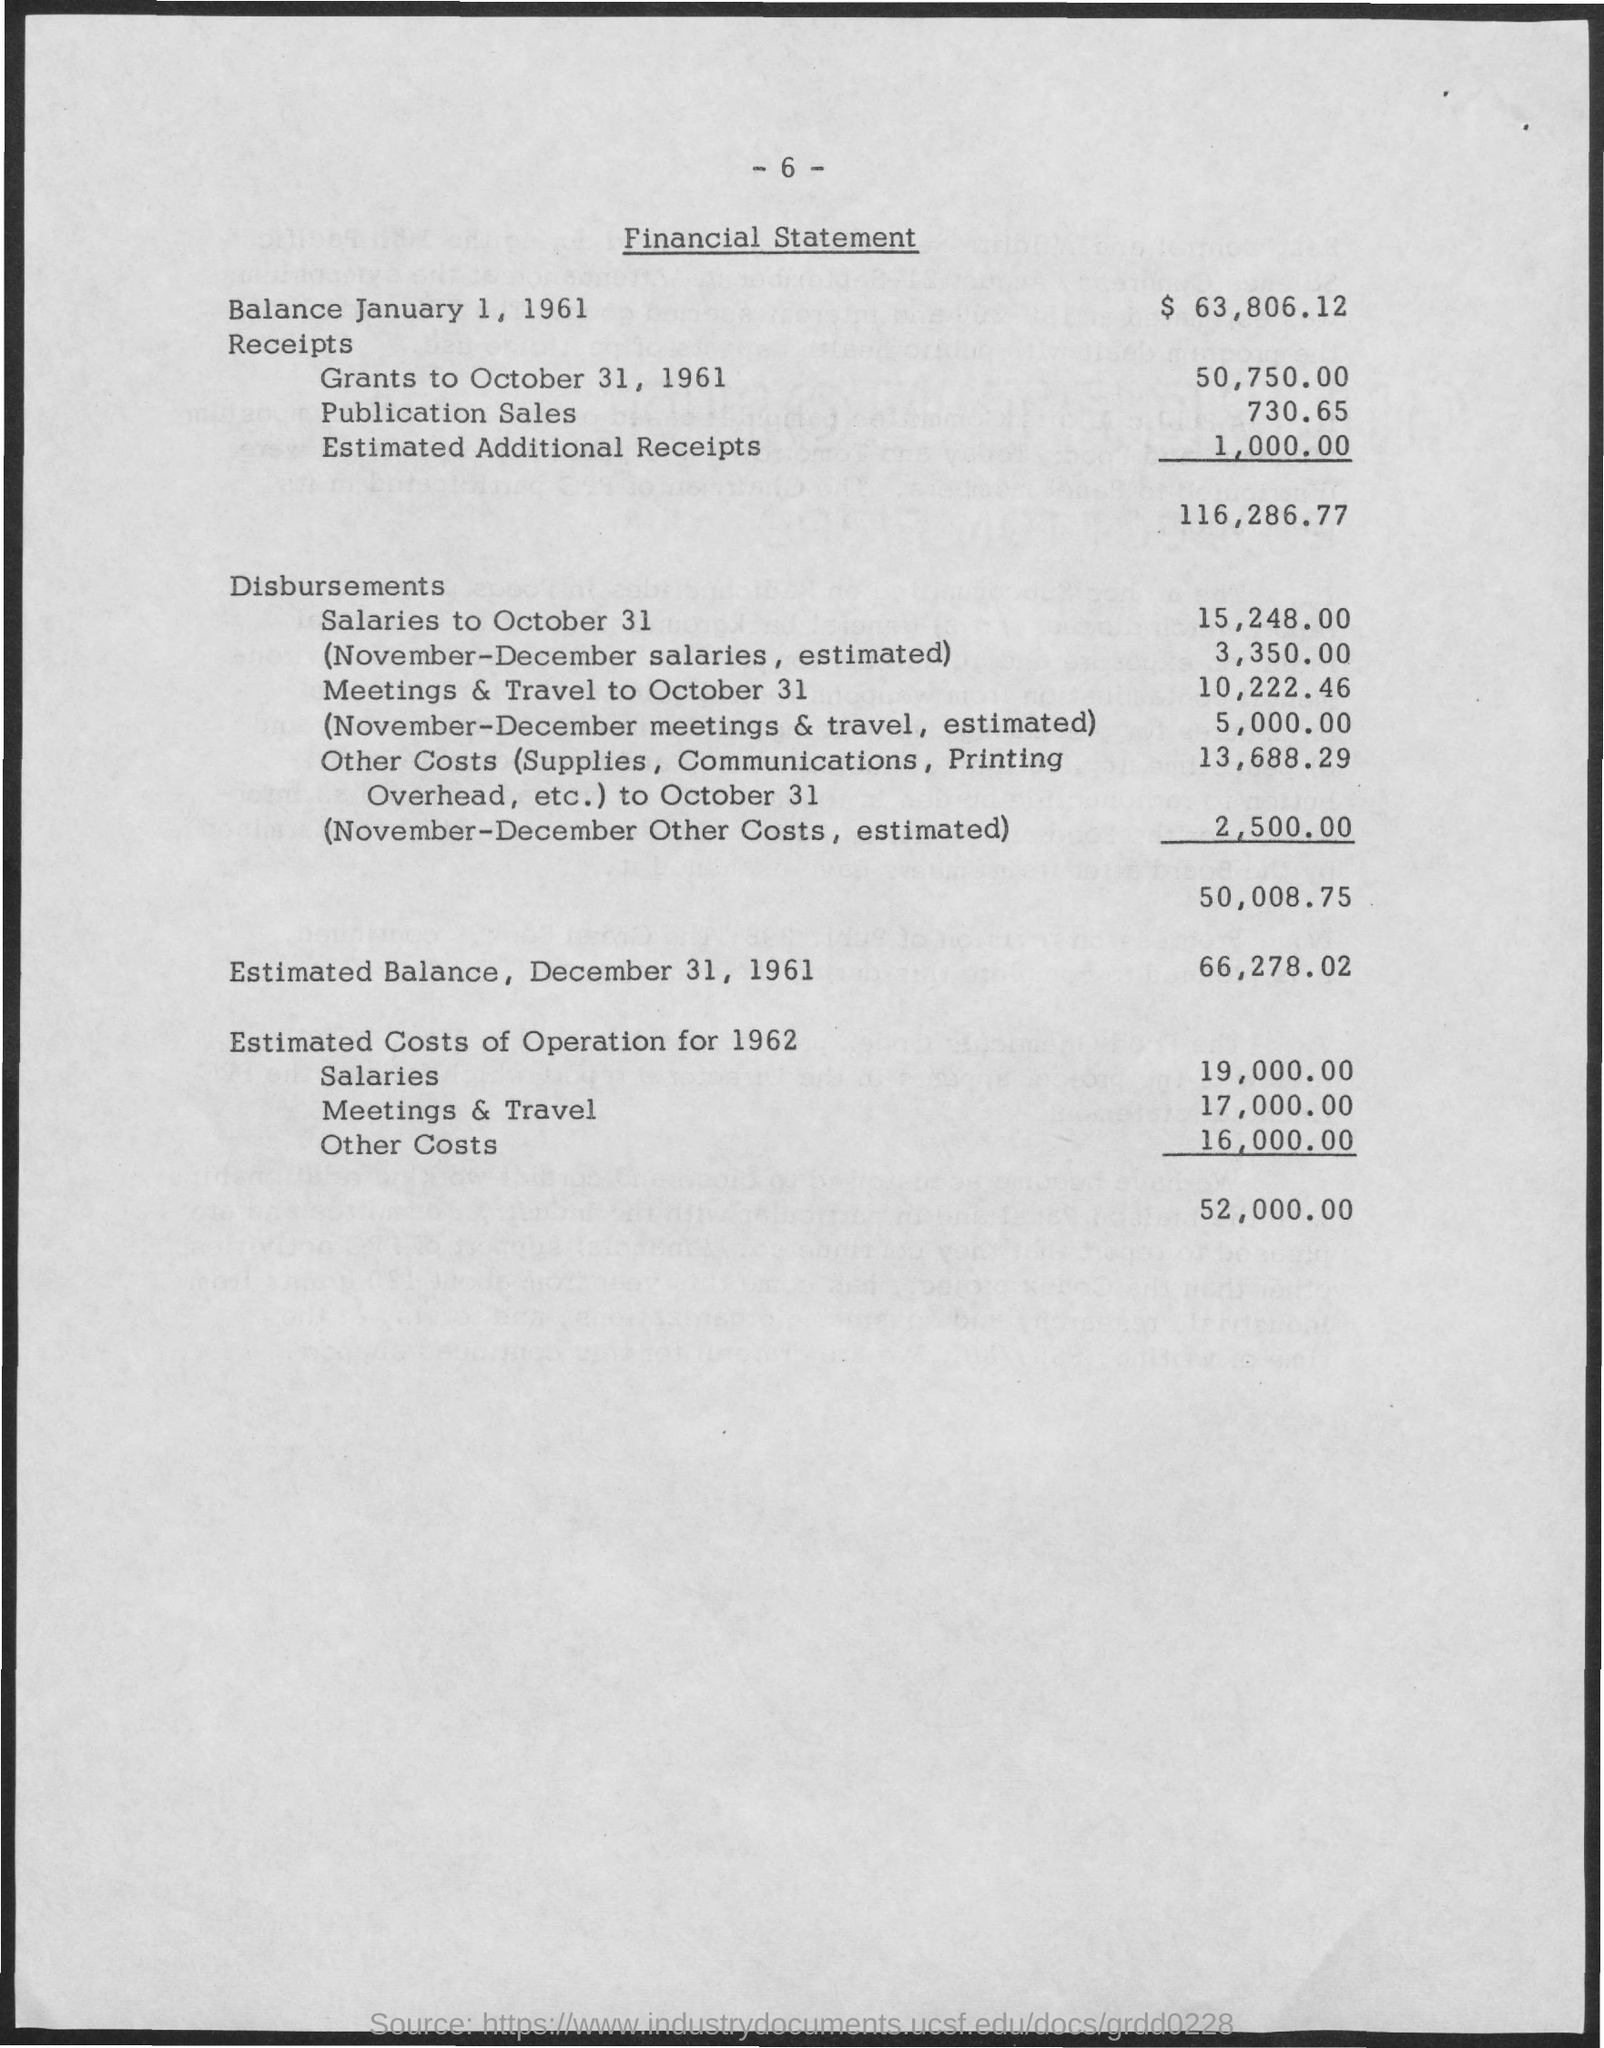Point out several critical features in this image. The cost of receipts for grants from October 31, 1961, was $50,750. On October 31, the disbursements for meetings and travel amounted to $10,222.46. The disbursements for salaries as of October 31 were 15,248.00. The estimated balance as of December 31, 1961, is 66,278.02. The cost of receipts for publication sales is 730.65 dollars. 